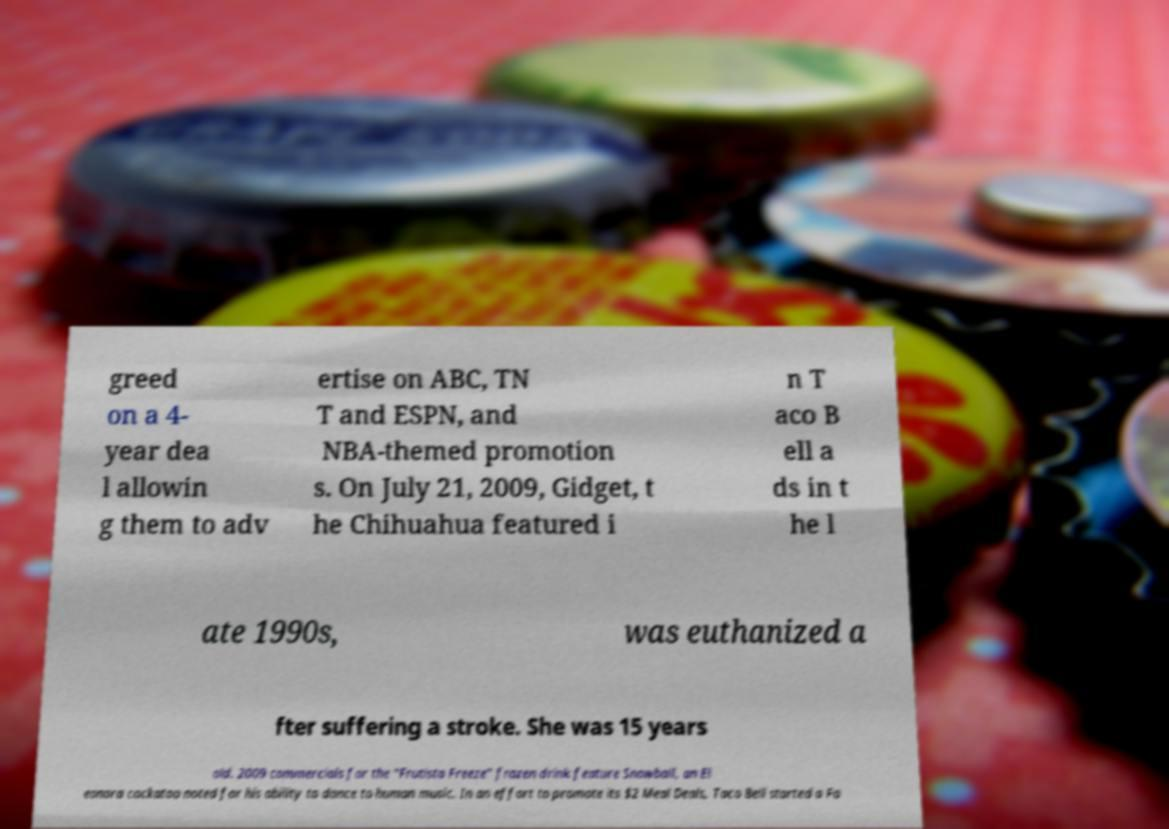Please read and relay the text visible in this image. What does it say? greed on a 4- year dea l allowin g them to adv ertise on ABC, TN T and ESPN, and NBA-themed promotion s. On July 21, 2009, Gidget, t he Chihuahua featured i n T aco B ell a ds in t he l ate 1990s, was euthanized a fter suffering a stroke. She was 15 years old. 2009 commercials for the "Frutista Freeze" frozen drink feature Snowball, an El eonora cockatoo noted for his ability to dance to human music. In an effort to promote its $2 Meal Deals, Taco Bell started a Fa 